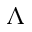Convert formula to latex. <formula><loc_0><loc_0><loc_500><loc_500>{ \Lambda }</formula> 